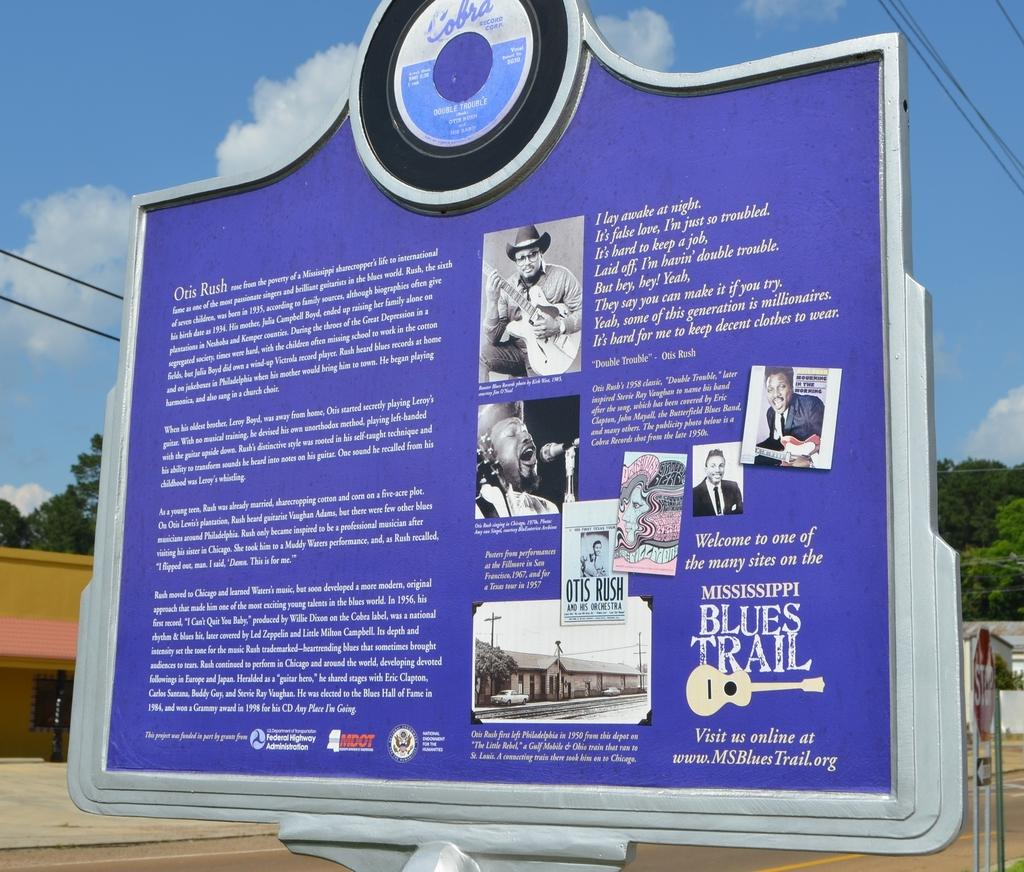What is the main object in the image? There is an information board in the image. What else can be seen in the image besides the information board? There are buildings, a shed, trees, electric cables, and the sky visible in the image. Can you describe the sky in the image? The sky is visible in the image, and clouds are present in the sky. What is the name of the person standing next to the shed in the image? There is no person standing next to the shed in the image. What color is the hair of the person sitting on the information board in the image? There is no person sitting on the information board in the image. 